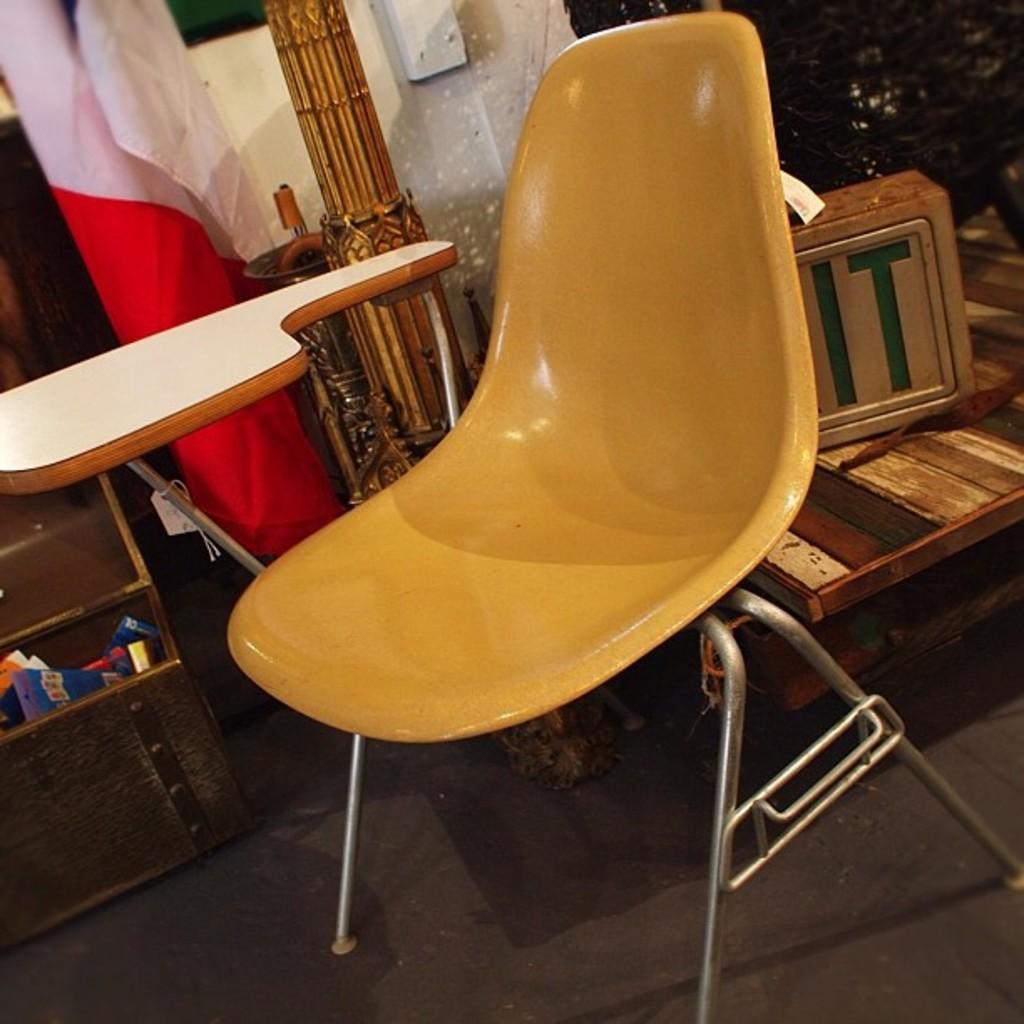Can you describe this image briefly? In this picture there is a yellow chair, beside that we can see the iron table. On the right we can see the wooden boxes. On the left there is a flag near to the rack. 